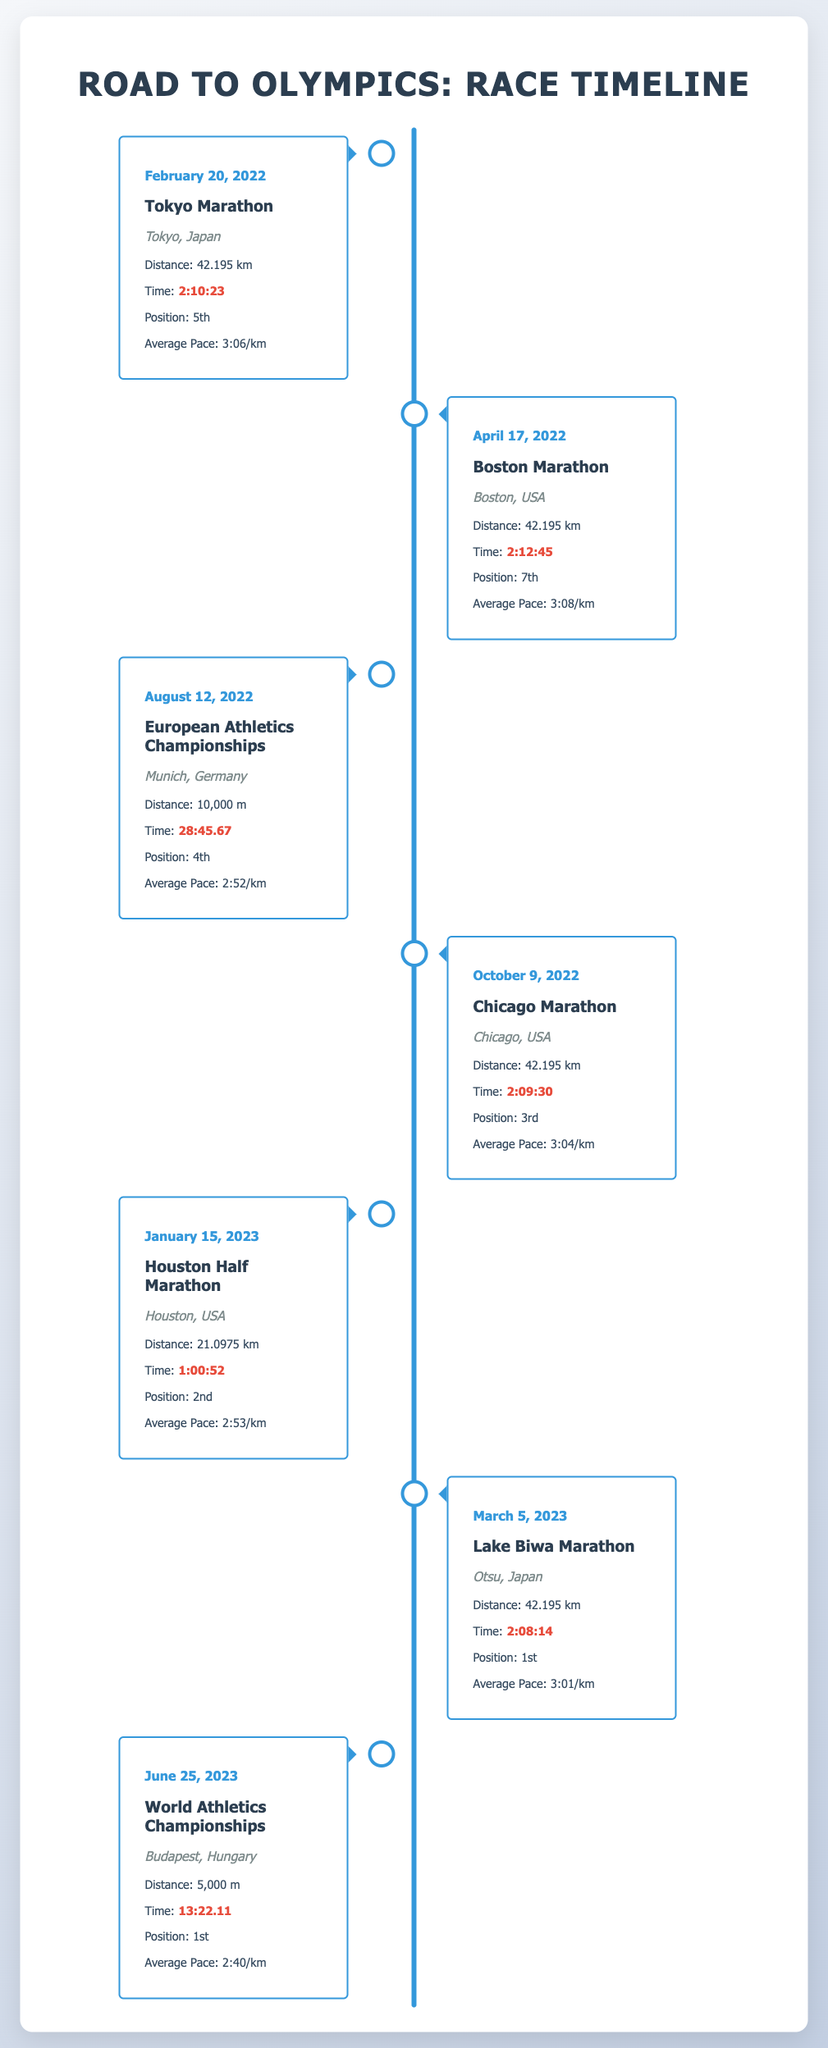What is the date of the Tokyo Marathon? The date of the Tokyo Marathon is explicitly stated in the timeline as February 20, 2022.
Answer: February 20, 2022 What was the distance of the European Athletics Championships? The document specifies that the event distance for the European Athletics Championships was 10,000 m.
Answer: 10,000 m What position did the runner achieve in the Lake Biwa Marathon? The runner's performance in the Lake Biwa Marathon shows that they achieved 1st position.
Answer: 1st Which event took place in Chicago? The event that took place in Chicago, as listed in the timeline, is the Chicago Marathon.
Answer: Chicago Marathon What was the average pace at the Houston Half Marathon? The average pace for the Houston Half Marathon is provided as 2:53/km in the performance metrics.
Answer: 2:53/km Which event did the runner perform best in? The runner performed best in the Lake Biwa Marathon with the best time of 2:08:14.
Answer: Lake Biwa Marathon What is the significance of June 25, 2023? June 25, 2023, marks the date of the World Athletics Championships where the runner finished in 1st place.
Answer: 1st place How many marathons did the runner participate in before 2023? The document lists four marathons prior to 2023: Tokyo, Boston, Chicago, and Lake Biwa.
Answer: Four marathons 